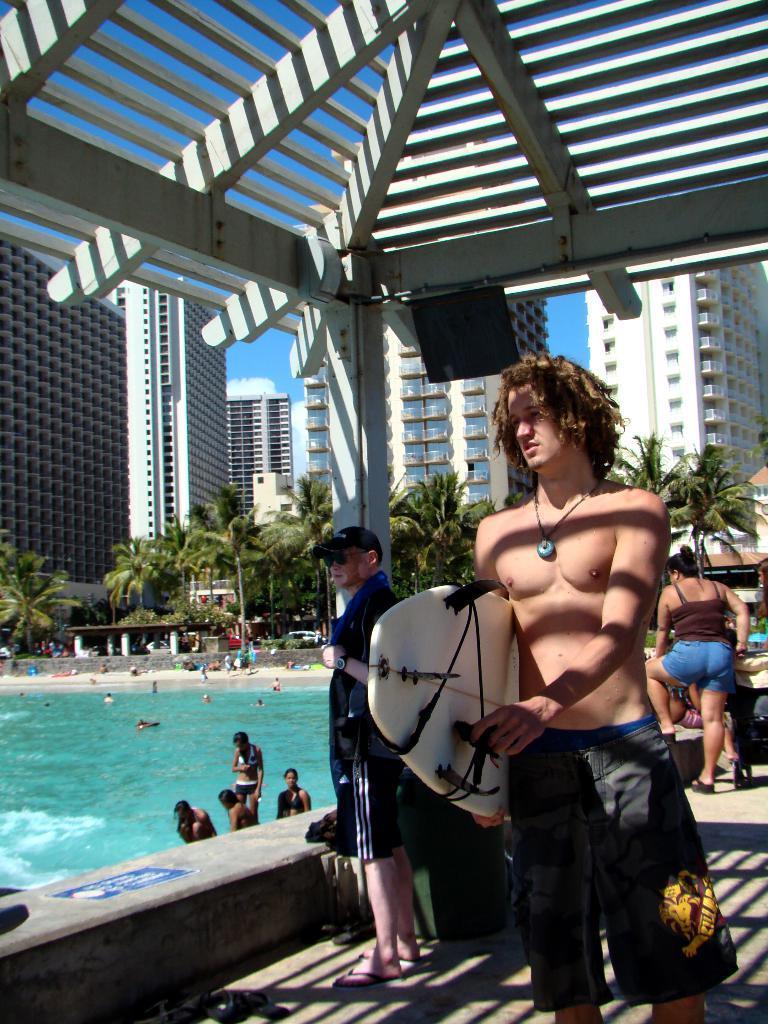Describe this image in one or two sentences. In this image there is a person standing and holding a surfing board in his hand, behind him there are a few people standing, above him there is a ceiling. On the left side of the image there are few people in the swimming pool. In the background there are a few people standing, trees, buildings and the sky. 